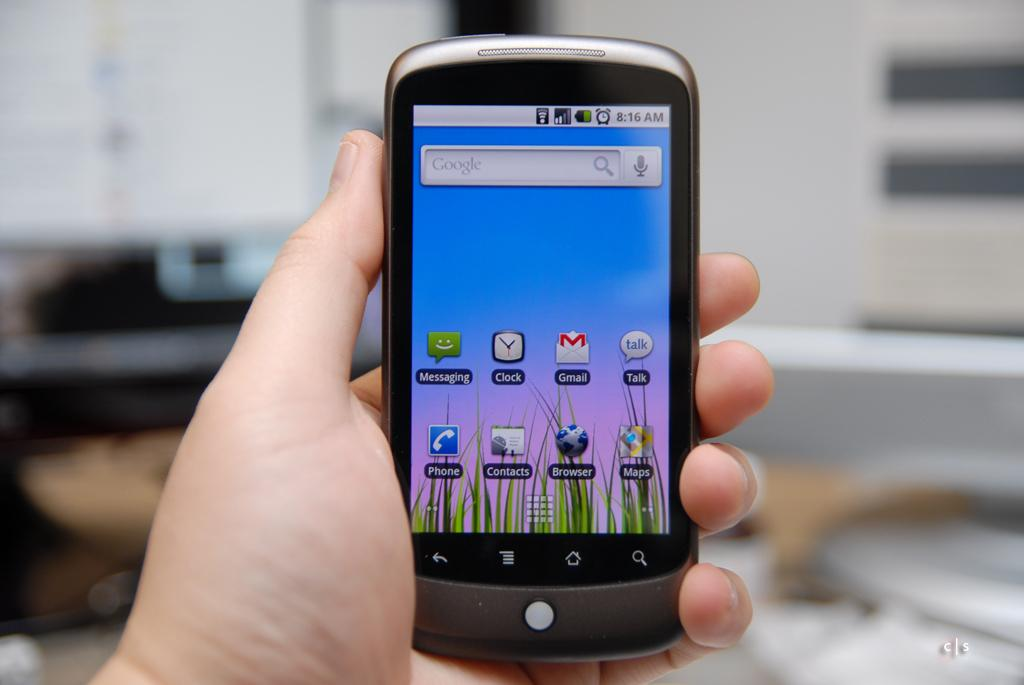<image>
Create a compact narrative representing the image presented. a phone with the time of 8:16 on it 